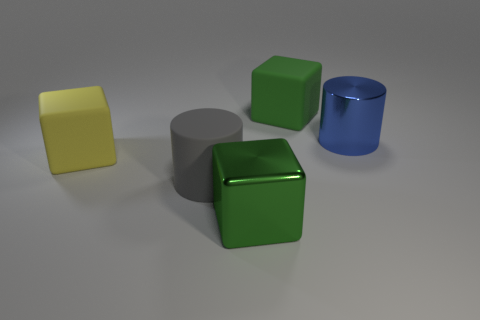How many objects are there, and can you classify them by shape? There are four objects in the image. Starting from the left, we have a yellow thin rectangular block, a medium-sized grey cylinder, a medium-sized green cube with a rubber texture, and a smaller, shiny blue cylinder. 